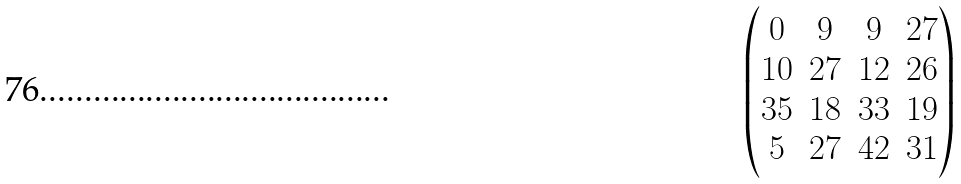Convert formula to latex. <formula><loc_0><loc_0><loc_500><loc_500>\begin{pmatrix} 0 & 9 & 9 & 2 7 \\ 1 0 & 2 7 & 1 2 & 2 6 \\ 3 5 & 1 8 & 3 3 & 1 9 \\ 5 & 2 7 & 4 2 & 3 1 \end{pmatrix}</formula> 